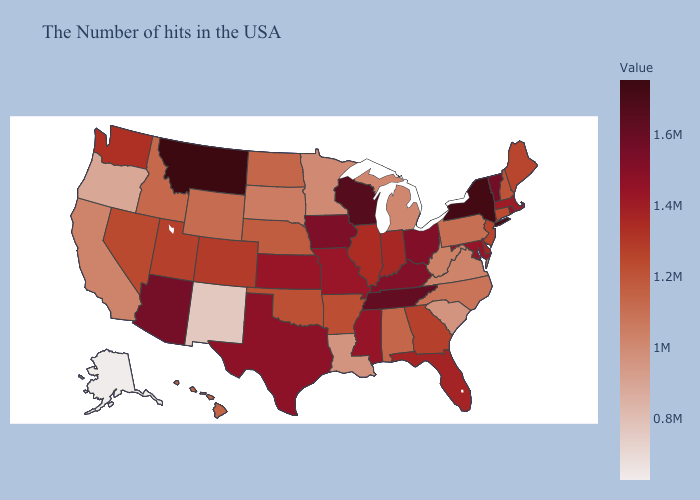Which states have the highest value in the USA?
Concise answer only. Montana. Among the states that border Delaware , does Pennsylvania have the highest value?
Keep it brief. No. Does Oregon have a lower value than Michigan?
Write a very short answer. Yes. Does Pennsylvania have the lowest value in the Northeast?
Answer briefly. Yes. Does Montana have the highest value in the West?
Write a very short answer. Yes. Which states have the lowest value in the USA?
Short answer required. Alaska. 